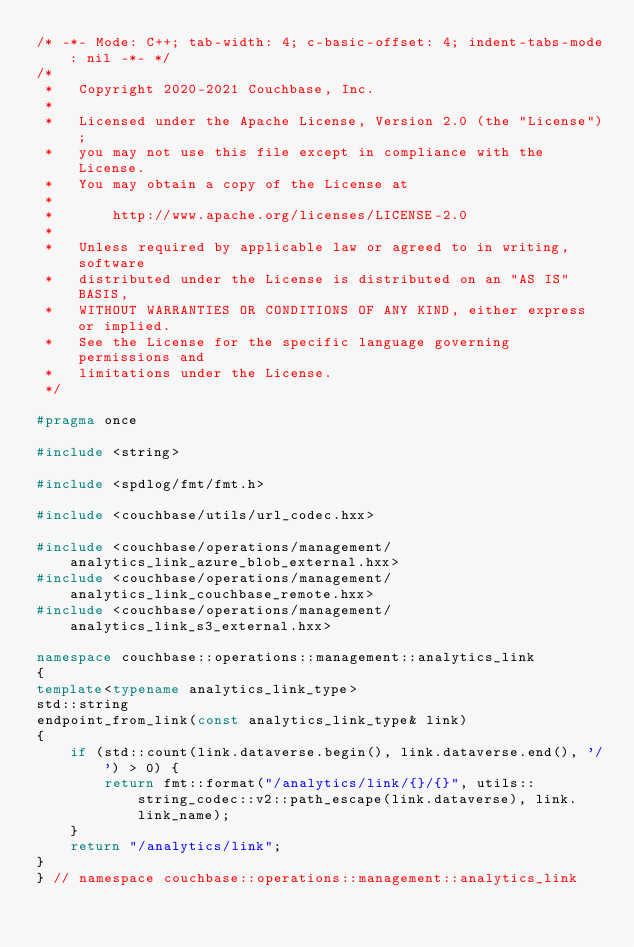Convert code to text. <code><loc_0><loc_0><loc_500><loc_500><_C++_>/* -*- Mode: C++; tab-width: 4; c-basic-offset: 4; indent-tabs-mode: nil -*- */
/*
 *   Copyright 2020-2021 Couchbase, Inc.
 *
 *   Licensed under the Apache License, Version 2.0 (the "License");
 *   you may not use this file except in compliance with the License.
 *   You may obtain a copy of the License at
 *
 *       http://www.apache.org/licenses/LICENSE-2.0
 *
 *   Unless required by applicable law or agreed to in writing, software
 *   distributed under the License is distributed on an "AS IS" BASIS,
 *   WITHOUT WARRANTIES OR CONDITIONS OF ANY KIND, either express or implied.
 *   See the License for the specific language governing permissions and
 *   limitations under the License.
 */

#pragma once

#include <string>

#include <spdlog/fmt/fmt.h>

#include <couchbase/utils/url_codec.hxx>

#include <couchbase/operations/management/analytics_link_azure_blob_external.hxx>
#include <couchbase/operations/management/analytics_link_couchbase_remote.hxx>
#include <couchbase/operations/management/analytics_link_s3_external.hxx>

namespace couchbase::operations::management::analytics_link
{
template<typename analytics_link_type>
std::string
endpoint_from_link(const analytics_link_type& link)
{
    if (std::count(link.dataverse.begin(), link.dataverse.end(), '/') > 0) {
        return fmt::format("/analytics/link/{}/{}", utils::string_codec::v2::path_escape(link.dataverse), link.link_name);
    }
    return "/analytics/link";
}
} // namespace couchbase::operations::management::analytics_link
</code> 